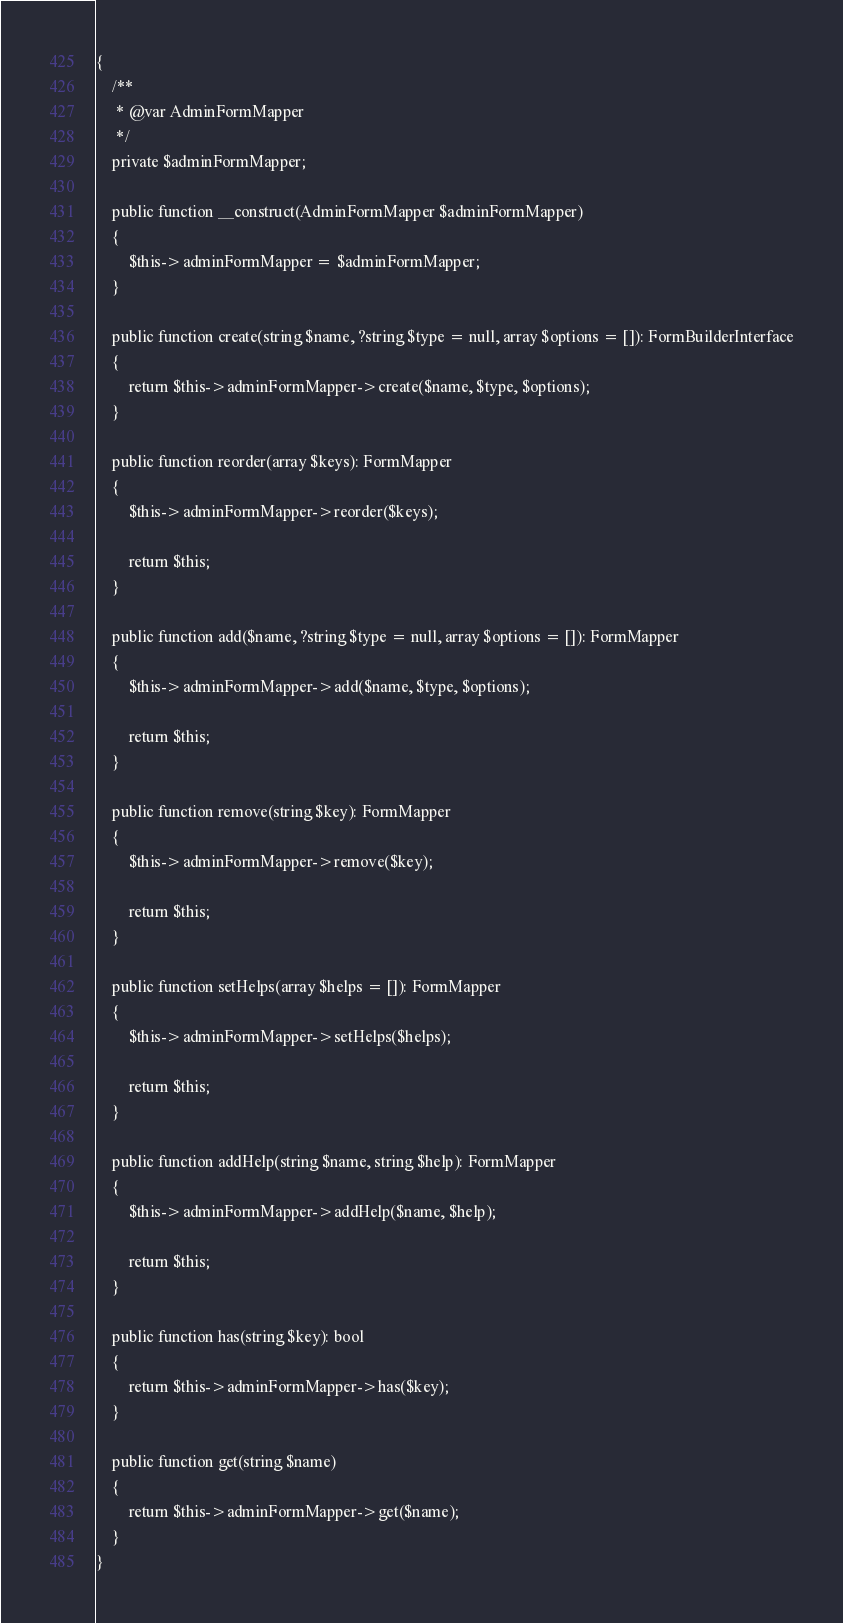<code> <loc_0><loc_0><loc_500><loc_500><_PHP_>{
    /**
     * @var AdminFormMapper
     */
    private $adminFormMapper;

    public function __construct(AdminFormMapper $adminFormMapper)
    {
        $this->adminFormMapper = $adminFormMapper;
    }

    public function create(string $name, ?string $type = null, array $options = []): FormBuilderInterface
    {
        return $this->adminFormMapper->create($name, $type, $options);
    }

    public function reorder(array $keys): FormMapper
    {
        $this->adminFormMapper->reorder($keys);

        return $this;
    }

    public function add($name, ?string $type = null, array $options = []): FormMapper
    {
        $this->adminFormMapper->add($name, $type, $options);

        return $this;
    }

    public function remove(string $key): FormMapper
    {
        $this->adminFormMapper->remove($key);

        return $this;
    }

    public function setHelps(array $helps = []): FormMapper
    {
        $this->adminFormMapper->setHelps($helps);

        return $this;
    }

    public function addHelp(string $name, string $help): FormMapper
    {
        $this->adminFormMapper->addHelp($name, $help);

        return $this;
    }

    public function has(string $key): bool
    {
        return $this->adminFormMapper->has($key);
    }

    public function get(string $name)
    {
        return $this->adminFormMapper->get($name);
    }
}
</code> 